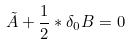<formula> <loc_0><loc_0><loc_500><loc_500>\tilde { A } + \frac { 1 } { 2 } * \delta _ { 0 } B = 0</formula> 